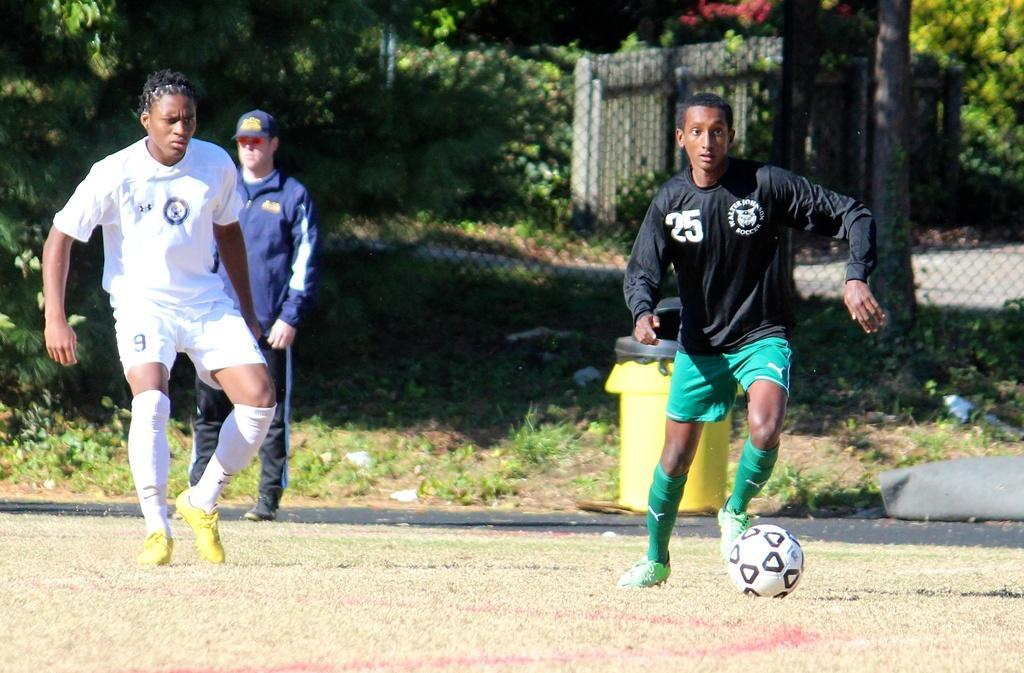Describe this image in one or two sentences. This image consist of a three persons. And three persons standing on the ground and on the right side a person throwing a ball And back side him there is a fence and there are some trees visible back side of the fence. 